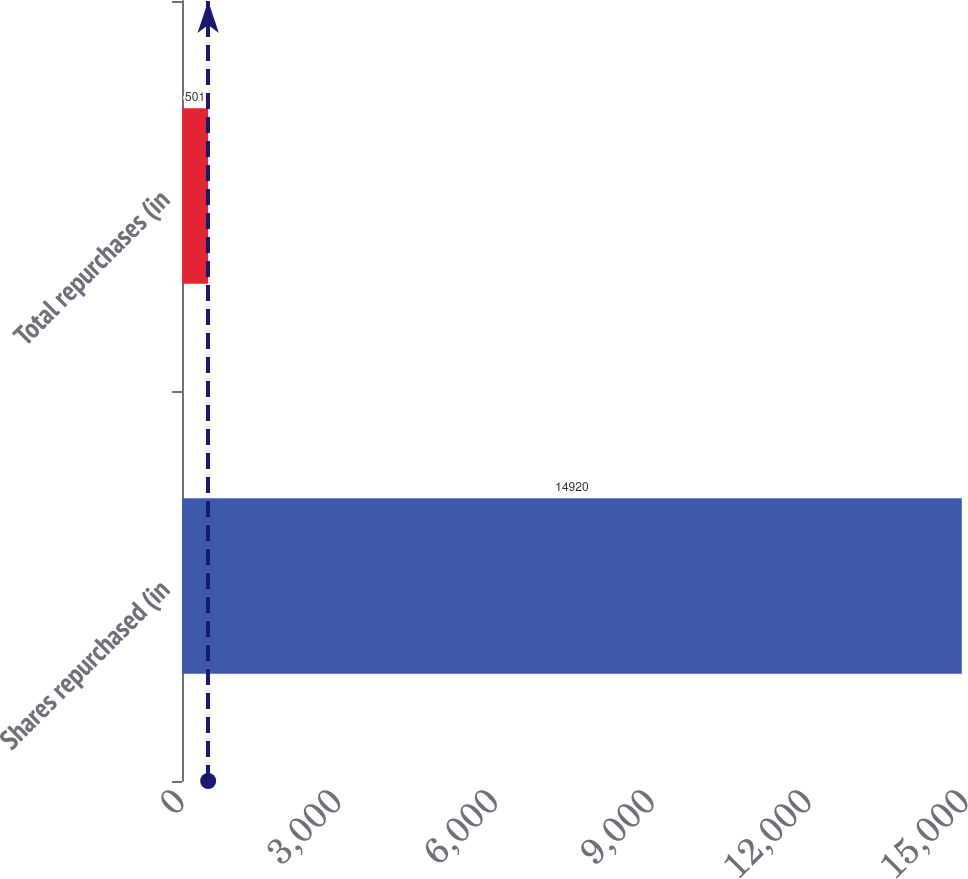Convert chart. <chart><loc_0><loc_0><loc_500><loc_500><bar_chart><fcel>Shares repurchased (in<fcel>Total repurchases (in<nl><fcel>14920<fcel>501<nl></chart> 